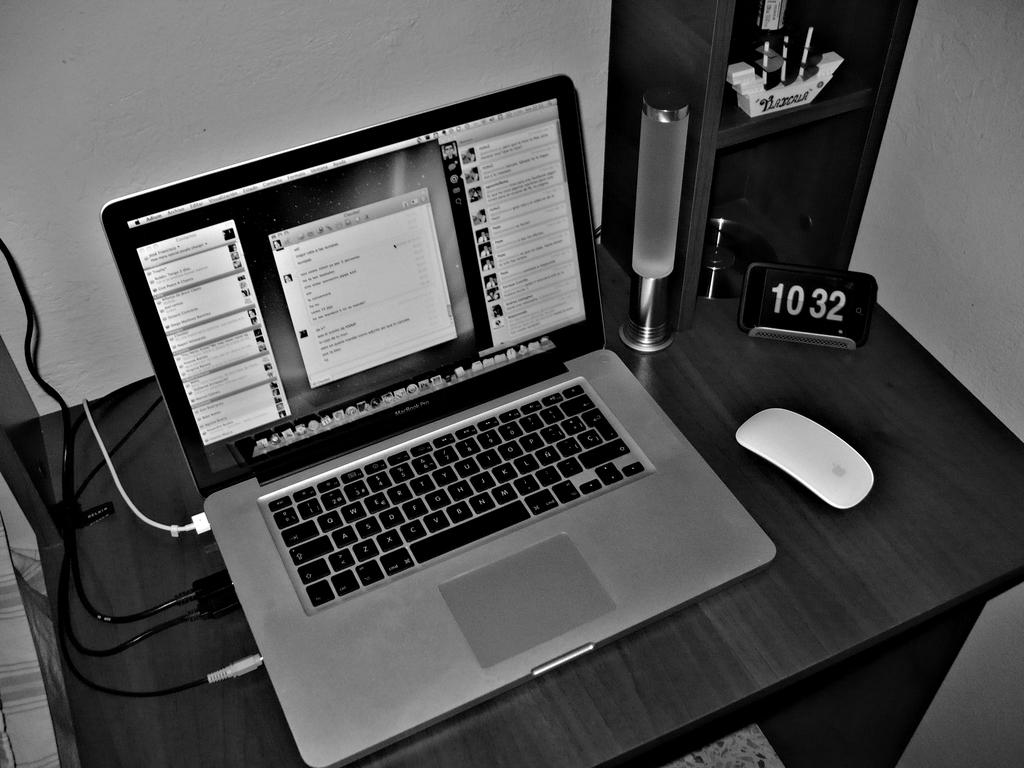What electronic device is visible in the image? There is a laptop in the image. What type of furniture or storage item is present in the image? There is a rack in the image. What material is the rack made of? The rack is made of metal. What is the circular object in the image? There is a disc in the image. Where is the disc placed? The disc is placed on a table. How would you describe the lighting in the image? The background of the image is dark. What invention is being demonstrated on the channel in the image? There is no channel or invention present in the image; it only features a laptop, rack, disc, table, and dark background. 